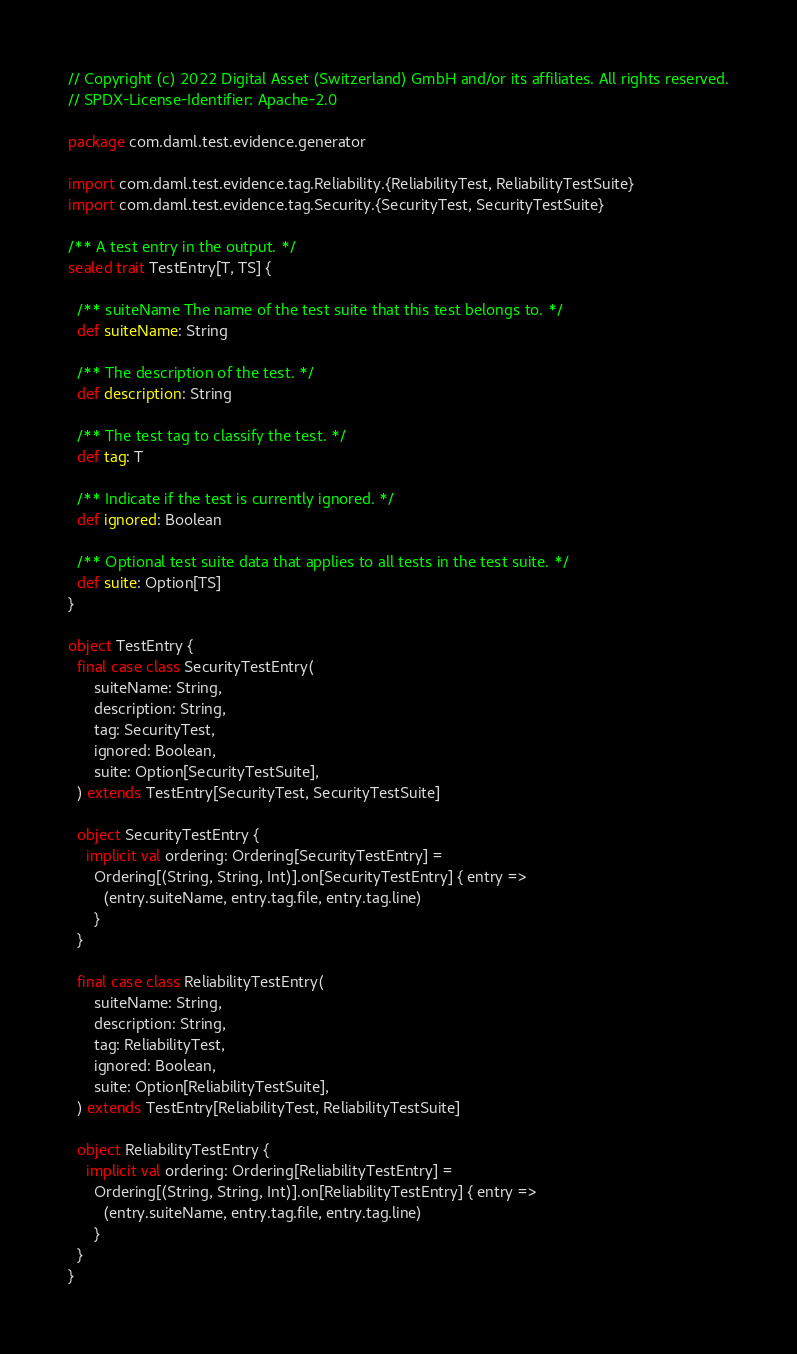Convert code to text. <code><loc_0><loc_0><loc_500><loc_500><_Scala_>// Copyright (c) 2022 Digital Asset (Switzerland) GmbH and/or its affiliates. All rights reserved.
// SPDX-License-Identifier: Apache-2.0

package com.daml.test.evidence.generator

import com.daml.test.evidence.tag.Reliability.{ReliabilityTest, ReliabilityTestSuite}
import com.daml.test.evidence.tag.Security.{SecurityTest, SecurityTestSuite}

/** A test entry in the output. */
sealed trait TestEntry[T, TS] {

  /** suiteName The name of the test suite that this test belongs to. */
  def suiteName: String

  /** The description of the test. */
  def description: String

  /** The test tag to classify the test. */
  def tag: T

  /** Indicate if the test is currently ignored. */
  def ignored: Boolean

  /** Optional test suite data that applies to all tests in the test suite. */
  def suite: Option[TS]
}

object TestEntry {
  final case class SecurityTestEntry(
      suiteName: String,
      description: String,
      tag: SecurityTest,
      ignored: Boolean,
      suite: Option[SecurityTestSuite],
  ) extends TestEntry[SecurityTest, SecurityTestSuite]

  object SecurityTestEntry {
    implicit val ordering: Ordering[SecurityTestEntry] =
      Ordering[(String, String, Int)].on[SecurityTestEntry] { entry =>
        (entry.suiteName, entry.tag.file, entry.tag.line)
      }
  }

  final case class ReliabilityTestEntry(
      suiteName: String,
      description: String,
      tag: ReliabilityTest,
      ignored: Boolean,
      suite: Option[ReliabilityTestSuite],
  ) extends TestEntry[ReliabilityTest, ReliabilityTestSuite]

  object ReliabilityTestEntry {
    implicit val ordering: Ordering[ReliabilityTestEntry] =
      Ordering[(String, String, Int)].on[ReliabilityTestEntry] { entry =>
        (entry.suiteName, entry.tag.file, entry.tag.line)
      }
  }
}
</code> 